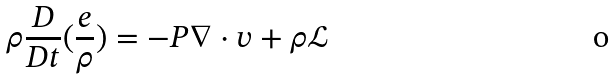Convert formula to latex. <formula><loc_0><loc_0><loc_500><loc_500>\rho \frac { D } { D t } ( \frac { e } { \rho } ) = - P { \nabla \cdot v } + \rho { \mathcal { L } }</formula> 